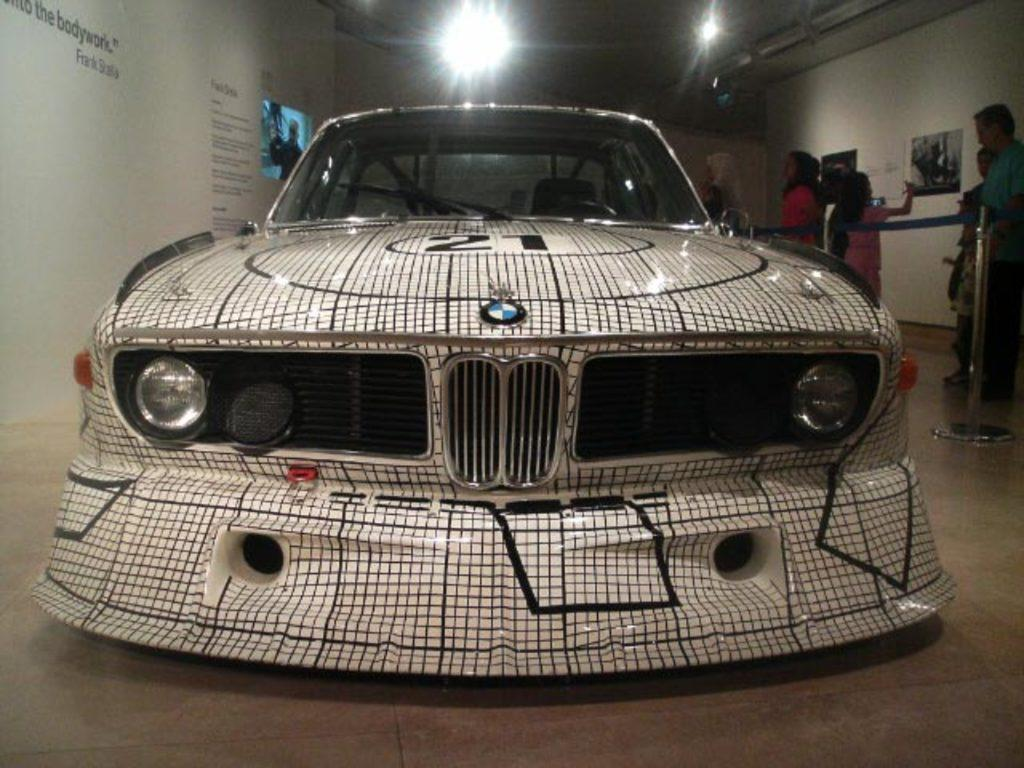What object is placed on the floor in the image? There is a car on the floor in the image. Can you describe the people visible in the image? There are people visible in the image. What type of illumination is present in the image? Lights are present in the image. What kind of barrier can be seen in the image? A stainless steel barrier is in the image. What decorative elements are on the walls in the image? There are posters on the walls in the image. What device is present in the image for displaying information or media? There is a screen in the image. What type of creature can be seen playing with the car in the image? There is no creature present in the image, and therefore no such activity can be observed. What season is depicted in the image, given the presence of snow and winter clothing? There is no mention of snow or winter clothing in the image, so it cannot be determined that the image depicts a specific season. 